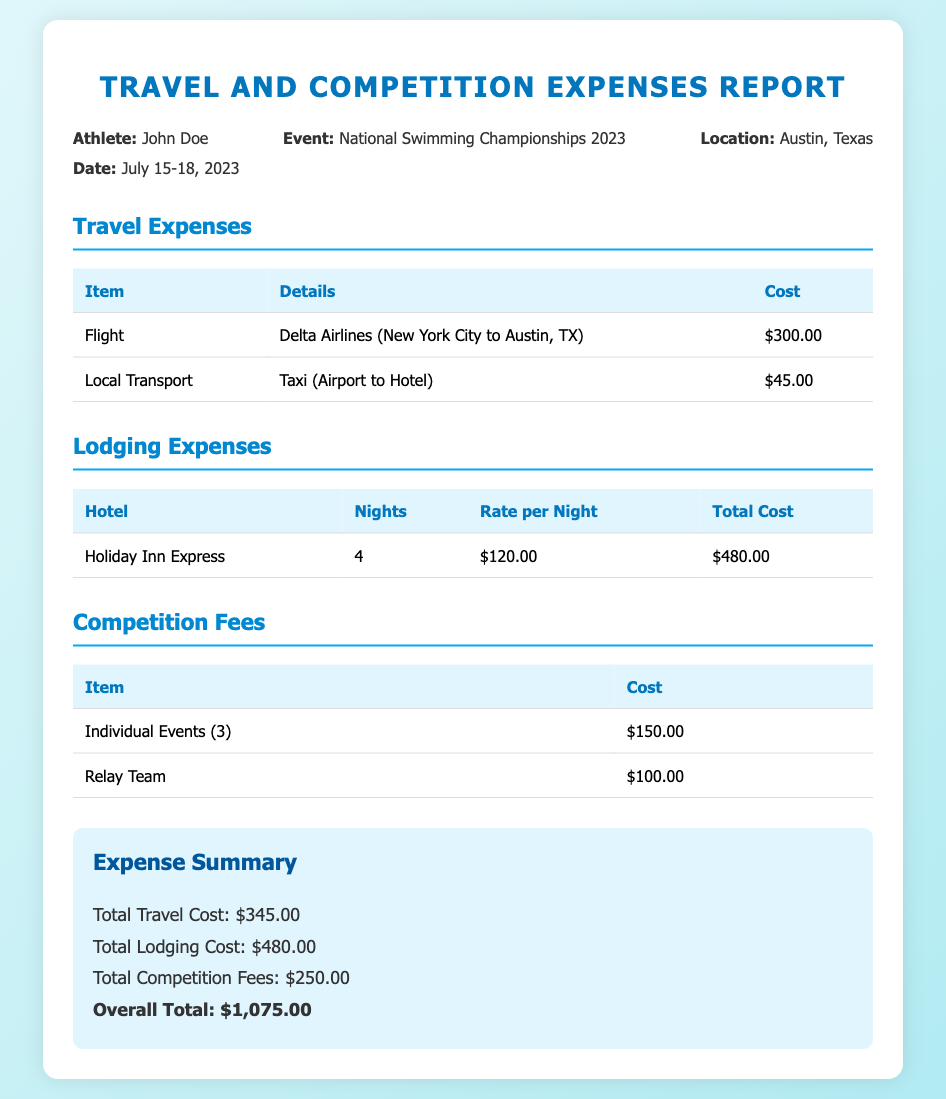What is the athlete's name? The athlete's name is stated in the document under the info section, which is John Doe.
Answer: John Doe What is the event being attended? The event is clearly mentioned in the info section as the National Swimming Championships 2023.
Answer: National Swimming Championships 2023 What is the location of the event? The location is provided in the info section as Austin, Texas.
Answer: Austin, Texas What is the cost of the flight? The cost of the flight is specified in the travel expenses table as $300.00.
Answer: $300.00 How many nights did the athlete stay at the hotel? The number of nights is mentioned in the lodging expenses table as 4 nights.
Answer: 4 What is the total cost for lodging? The total cost for lodging is provided in the lodging expenses section as $480.00.
Answer: $480.00 How much was paid for competition fees? The total competition fees are outlined in the competition fees table as $250.00.
Answer: $250.00 What is the overall total expense? The overall total is clearly summarized at the end of the document as $1,075.00.
Answer: $1,075.00 How much did local transport cost? The cost for local transport is listed in the travel expenses table as $45.00.
Answer: $45.00 